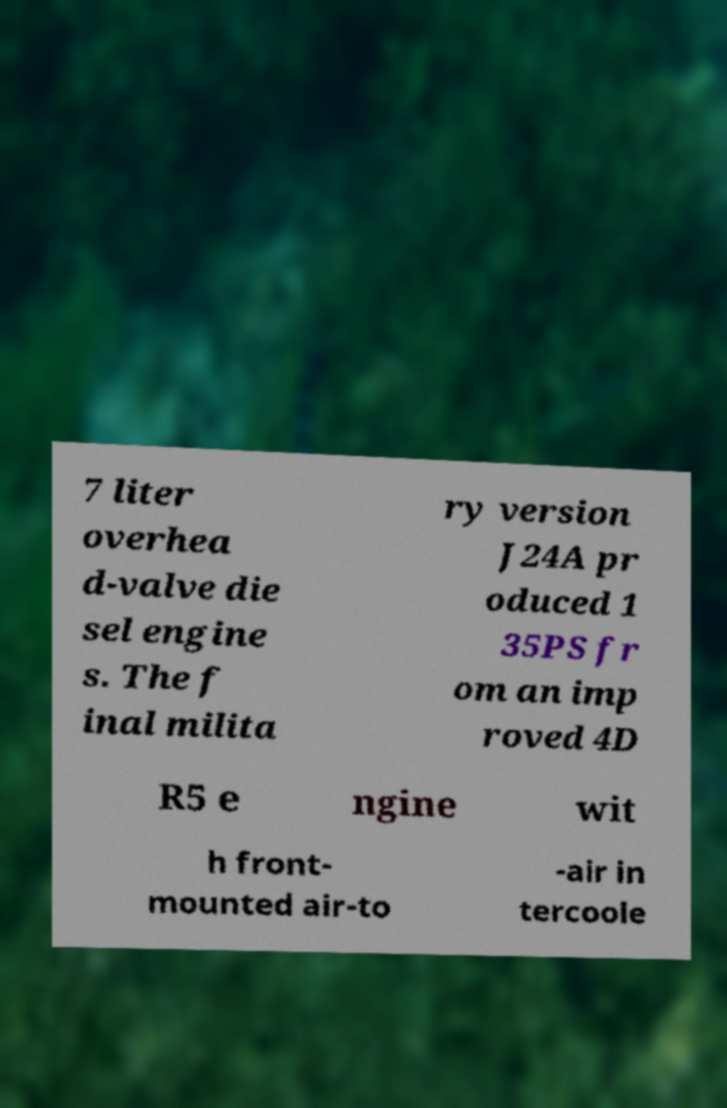Can you accurately transcribe the text from the provided image for me? 7 liter overhea d-valve die sel engine s. The f inal milita ry version J24A pr oduced 1 35PS fr om an imp roved 4D R5 e ngine wit h front- mounted air-to -air in tercoole 